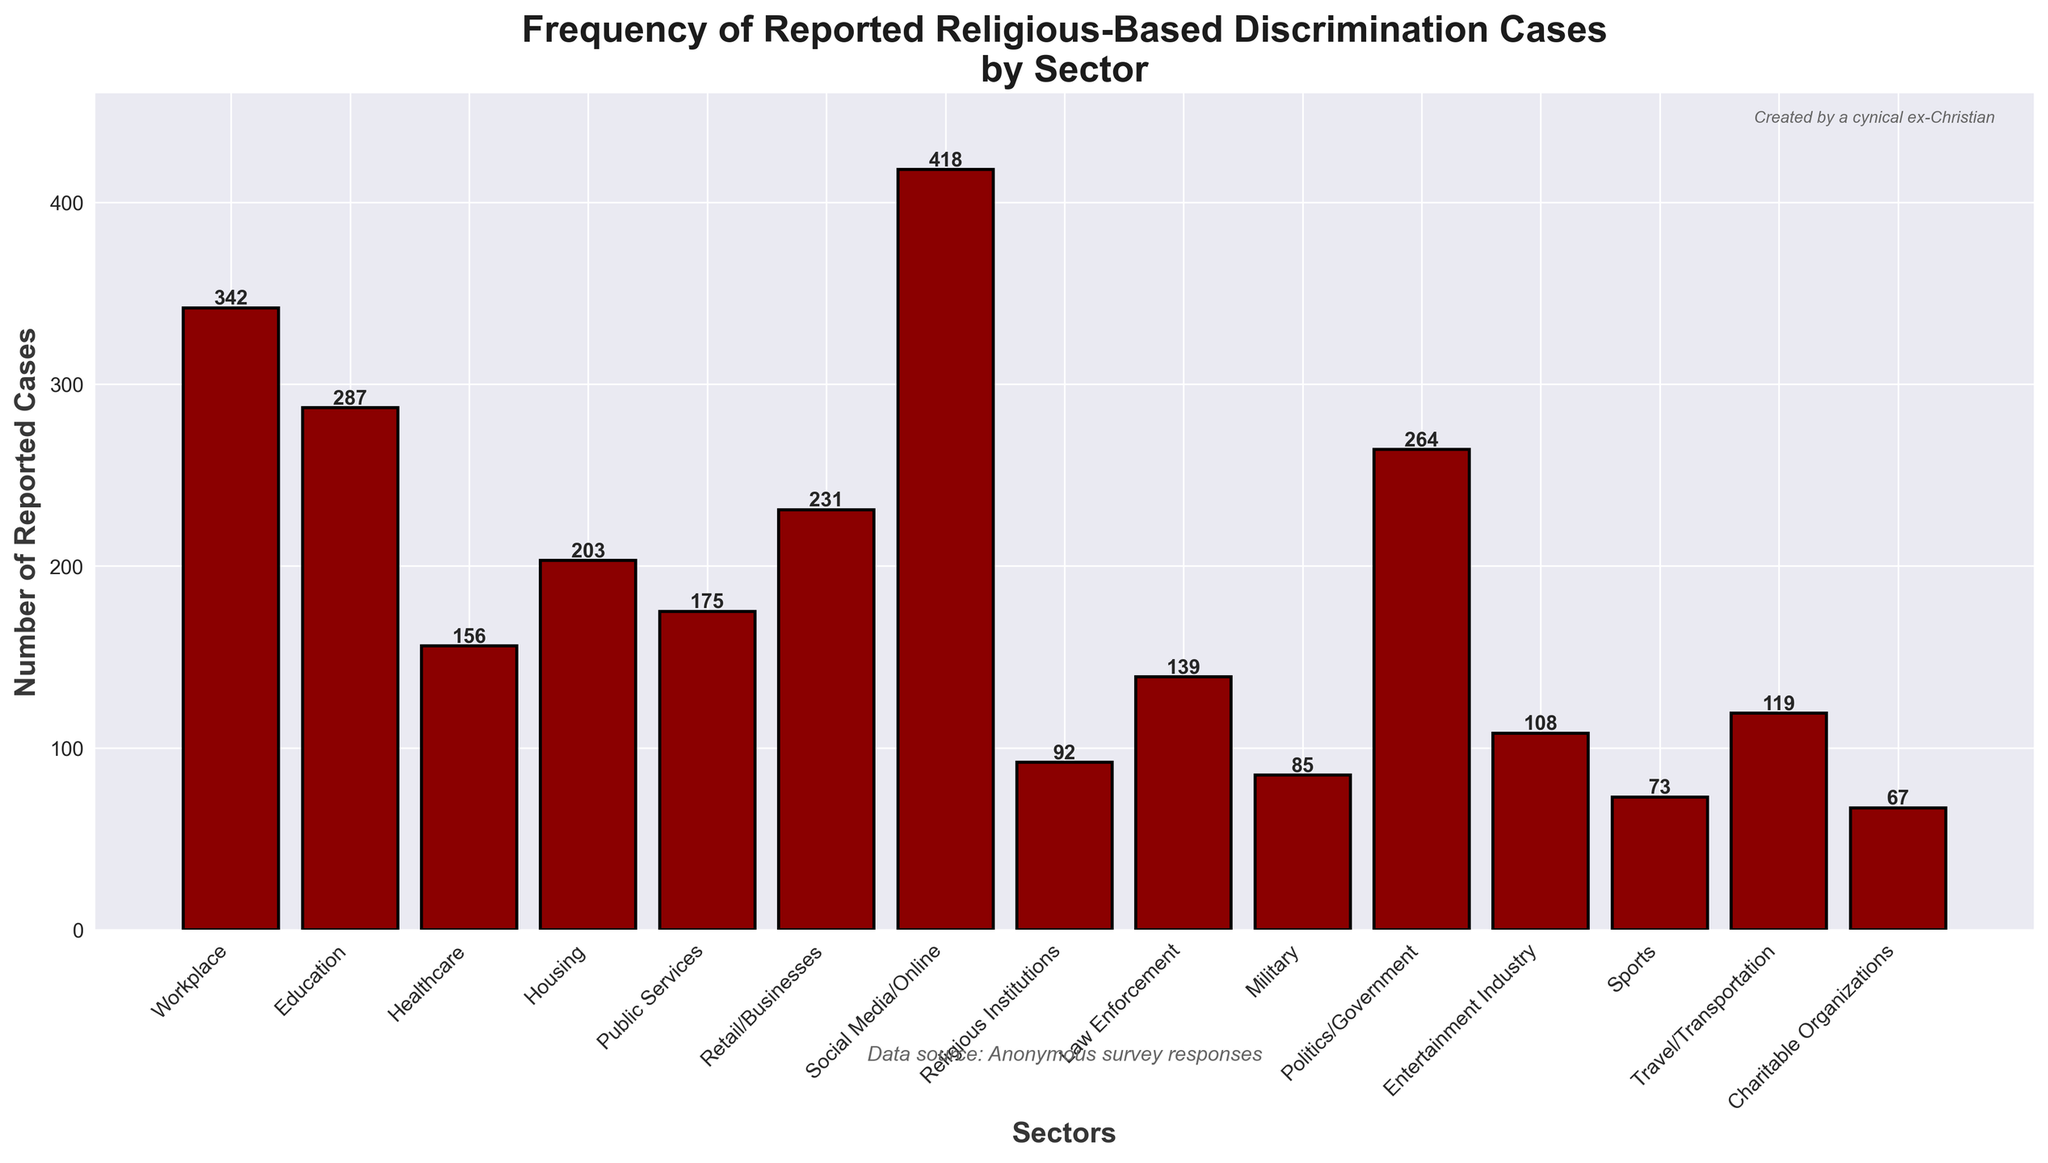Which sector has the highest number of reported religious-based discrimination cases? The tallest bar represents the sector with the highest number of reported cases. According to the figure, the "Social Media/Online" sector has the highest bar.
Answer: Social Media/Online Which sector has the fewest reported cases of religious-based discrimination? The shortest bar represents the sector with the fewest reported cases. According to the figure, the "Charitable Organizations" sector has the shortest bar.
Answer: Charitable Organizations How many more reported cases are there in "Workplace" compared to "Religious Institutions"? Subtract the number of reported cases in "Religious Institutions" from those in "Workplace": 342 - 92 = 250.
Answer: 250 What is the average number of reported religious-based discrimination cases across all sectors? Add all the reported cases together and divide by the number of sectors: (342 + 287 + 156 + 203 + 175 + 231 + 418 + 92 + 139 + 85 + 264 + 108 + 73 + 119 + 67) / 15 = 172.2
Answer: 172.2 Are there more reported cases in "Healthcare" or "Law Enforcement"? Compare the heights of the bars for "Healthcare" and "Law Enforcement". The bar for "Healthcare" is taller (156) than that for "Law Enforcement" (139).
Answer: Healthcare What is the total number of reported cases in "Education", "Healthcare", and "Housing" combined? Add the reported cases in the three sectors together: 287 + 156 + 203 = 646.
Answer: 646 Which sectors have reported cases greater than 200? Identify bars taller than 200. The sectors are "Workplace" (342), "Education" (287), "Housing" (203), "Retail/Businesses" (231), "Social Media/Online" (418), and "Politics/Government" (264).
Answer: Workplace, Education, Housing, Retail/Businesses, Social Media/Online, Politics/Government Which is more, the sum of reported cases in "Military" and "Entertainment Industry" or "Public Services"? Calculate each sum and compare: Military + Entertainment Industry = 85 + 108 = 193, Public Services = 175. 193 is greater than 175.
Answer: Military and Entertainment Industry By how much do reported cases in "Social Media/Online" exceed those in "Education"? Subtract the number of reported cases in "Education" from those in "Social Media/Online": 418 - 287 = 131.
Answer: 131 